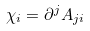<formula> <loc_0><loc_0><loc_500><loc_500>\chi _ { i } = \partial ^ { j } A _ { j i }</formula> 